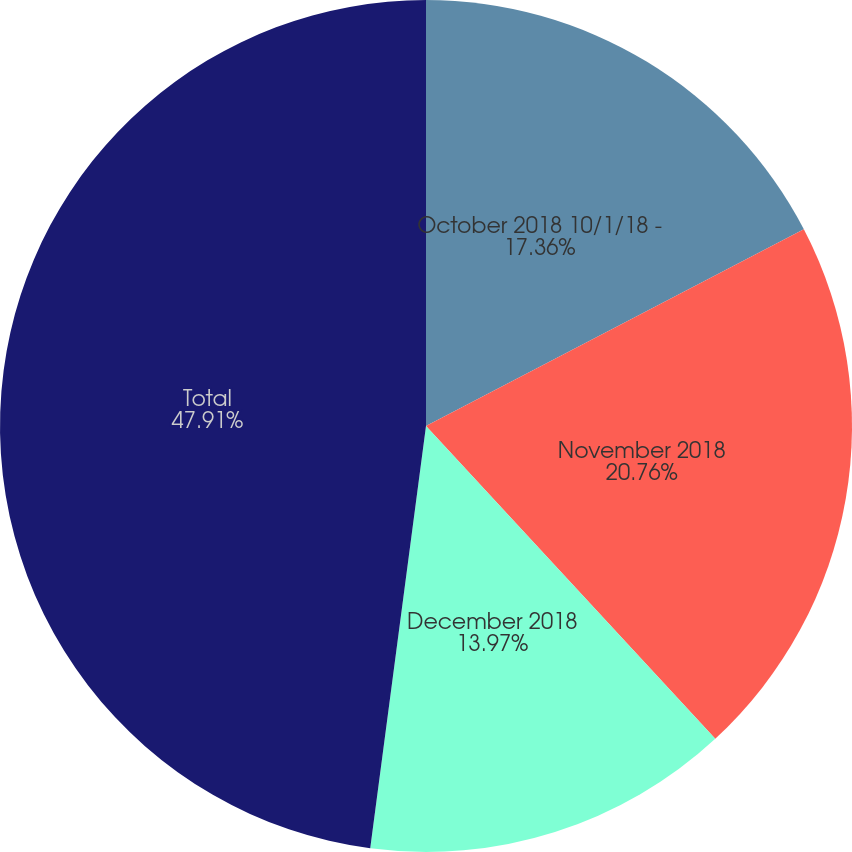Convert chart to OTSL. <chart><loc_0><loc_0><loc_500><loc_500><pie_chart><fcel>October 2018 10/1/18 -<fcel>November 2018<fcel>December 2018<fcel>Total<nl><fcel>17.36%<fcel>20.76%<fcel>13.97%<fcel>47.91%<nl></chart> 